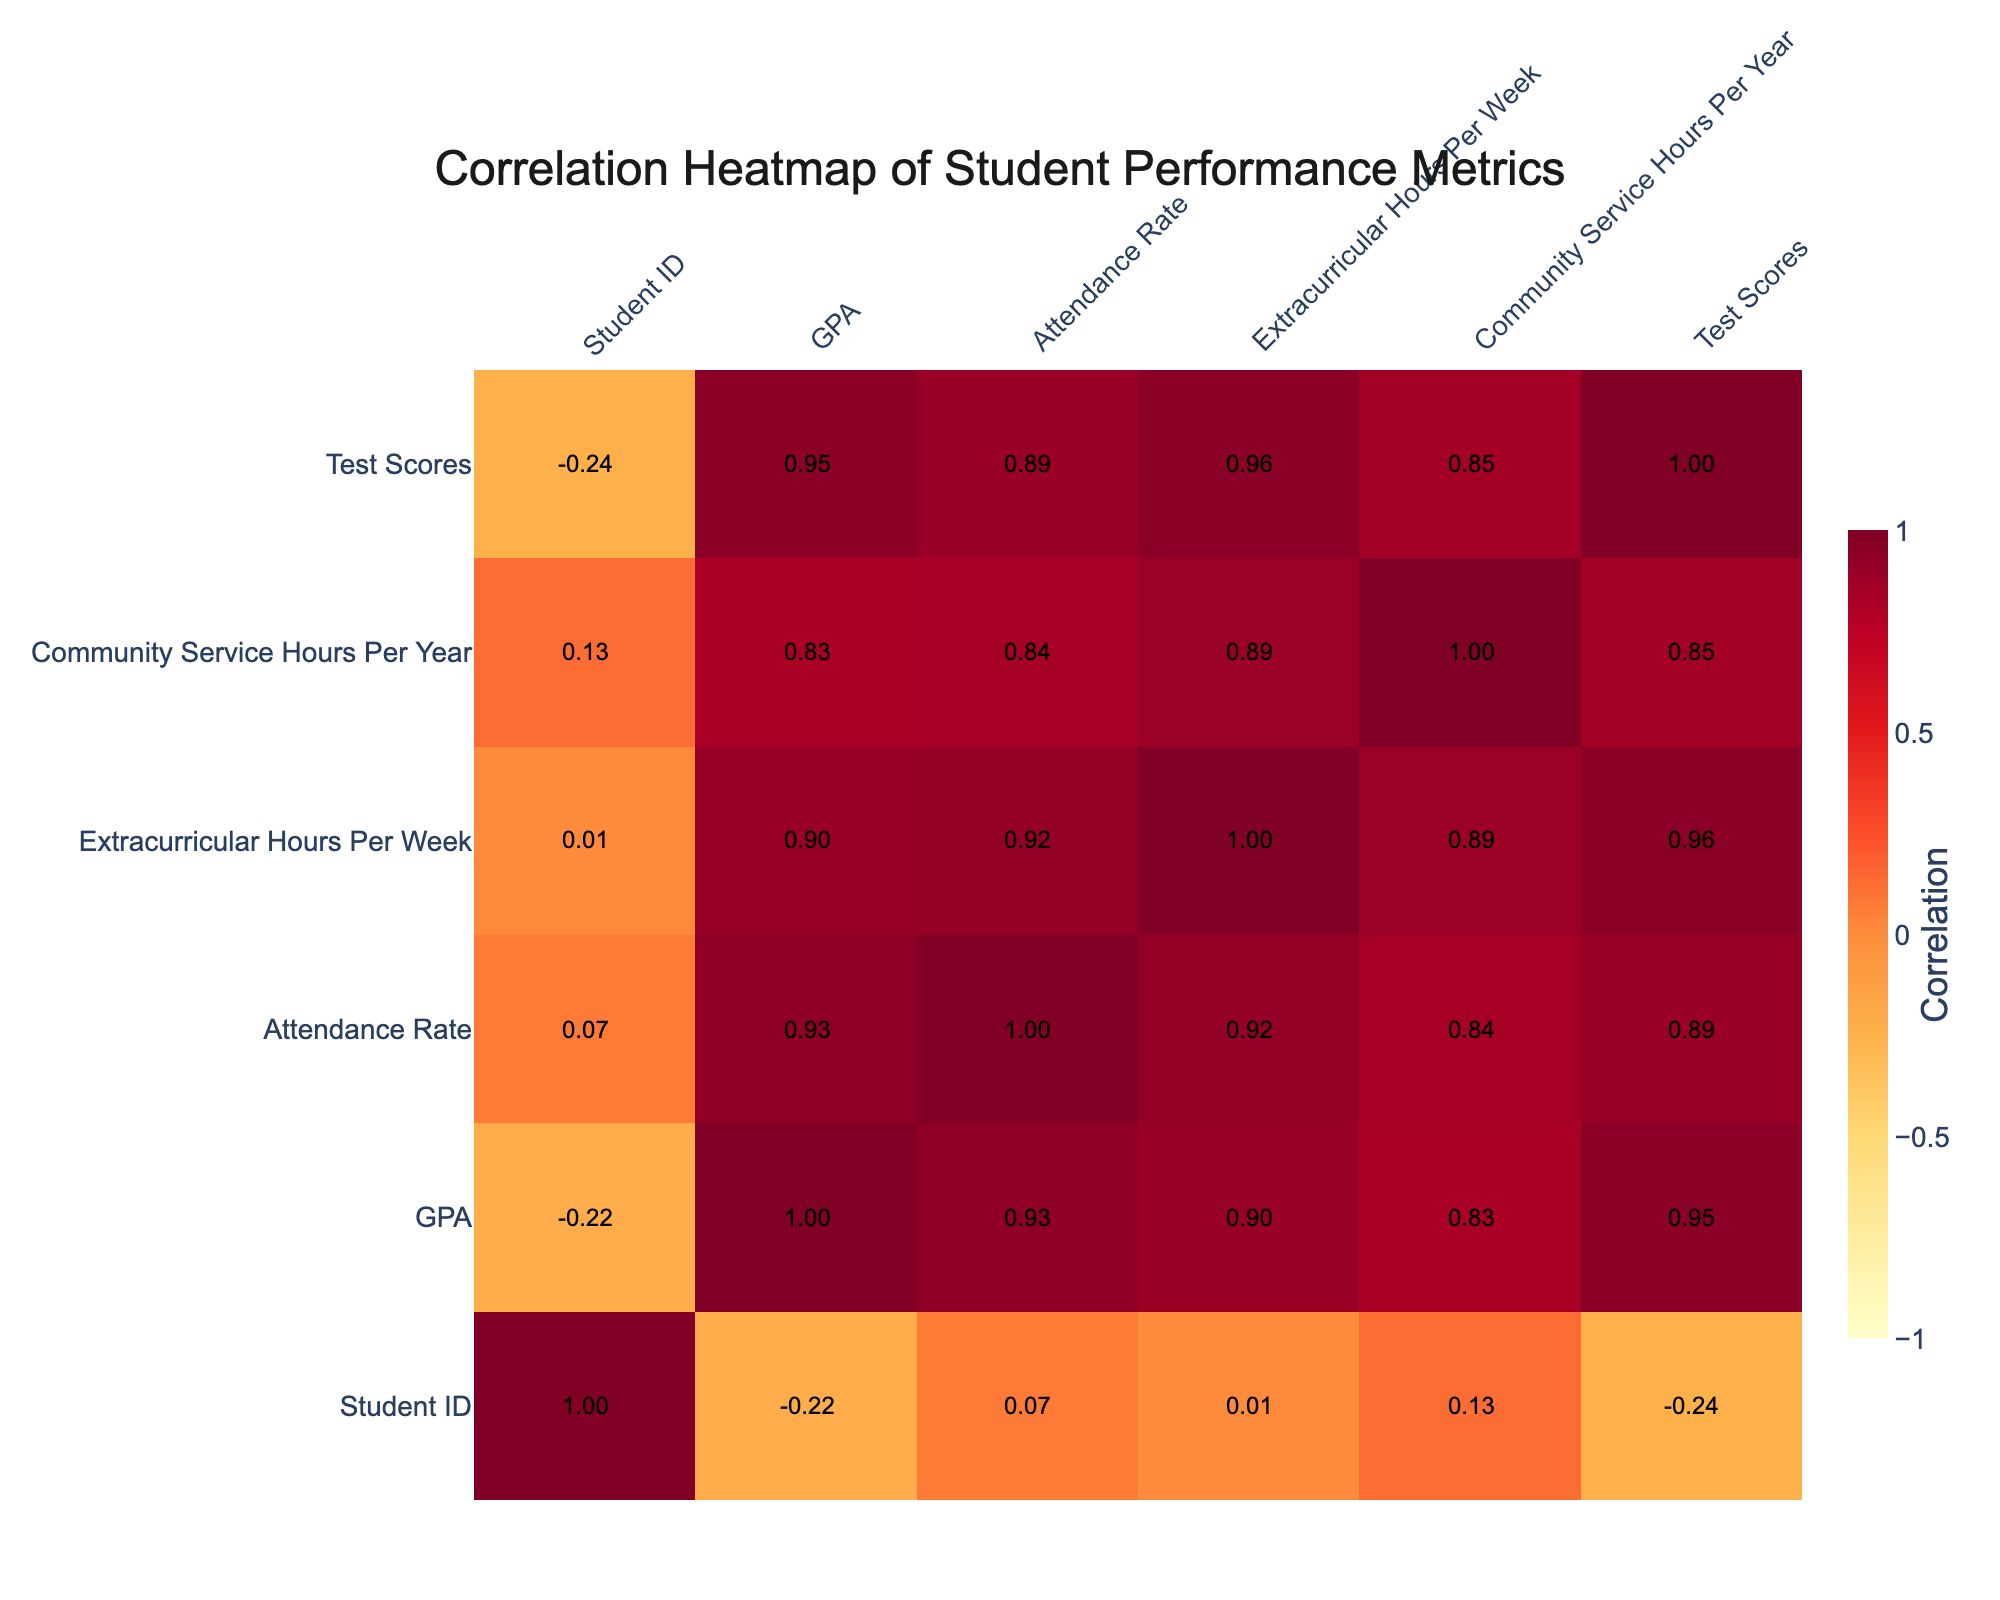What is the correlation between GPA and Test Scores? The correlation value between GPA and Test Scores can be directly found by looking at the intersection of the GPA row and Test Scores column in the correlation table. From the table, this value is approximately 0.90, which indicates a strong positive correlation.
Answer: 0.90 What is the average attendance rate for students who participate in extracurricular activities for more than 10 hours per week? First, we need to identify which students participate in extracurricular activities for more than 10 hours per week. Students 3, 6, and 7 fit this criterion with attendance rates of 98, 94, and 100 respectively. Next, we calculate the average: (98 + 94 + 100) / 3 = 98.67.
Answer: 98.67 Does a higher number of Community Service Hours correlate with higher GPA? To determine this, we check the correlation value between Community Service Hours and GPA in the table. The correlation value is approximately 0.45, which indicates a moderate positive correlation, suggesting that as community service hours increase, GPA tends to also increase.
Answer: Yes Which student had the highest Test Scores and what was their GPA? Student 7 had the highest Test Score of 1550. Referring to the Student_ID 7 entry in the table reveals that their GPA is 4.0.
Answer: 4.0 Is it true that the student with the highest GPA also has the highest number of Extracurricular Hours? Student 7 does indeed have the highest GPA of 4.0, having participated in 15 Extracurricular Hours. However, Student 3 has 12 Extracurricular Hours with a GPA of 3.9, meaning the student with the highest GPA does have the highest Extracurricular Hours.
Answer: Yes What is the difference in Test Scores between the student with the highest and lowest GPA? The student with the highest GPA is Student 7 with a Test Score of 1550 and the lowest GPA is Student 4 with a Test Score of 1200. The difference is 1550 - 1200 = 350.
Answer: 350 What is the correlation between Extracurricular Hours and Attendance Rate? We locate the correlation value in the correlation table at the intersection of the Extracurricular Hours and Attendance Rate. This value is approximately 0.60, indicating a moderate positive correlation.
Answer: 0.60 What is the median GPA of the students listed in the table? First, we list the GPAs in order: 2.9, 3.1, 3.3, 3.4, 3.5, 3.6, 3.7, 3.8, 3.9, 4.0, which consists of 10 values. The median will be the average of the 5th and 6th values: (3.5 + 3.6) / 2 = 3.55.
Answer: 3.55 What is the correlation between Attendance Rate and Community Service Hours? We look for the correlation value where Attendance Rate and Community Service Hours intersect. According to the correlation table, this value is approximately 0.10, indicating a very weak relationship.
Answer: 0.10 